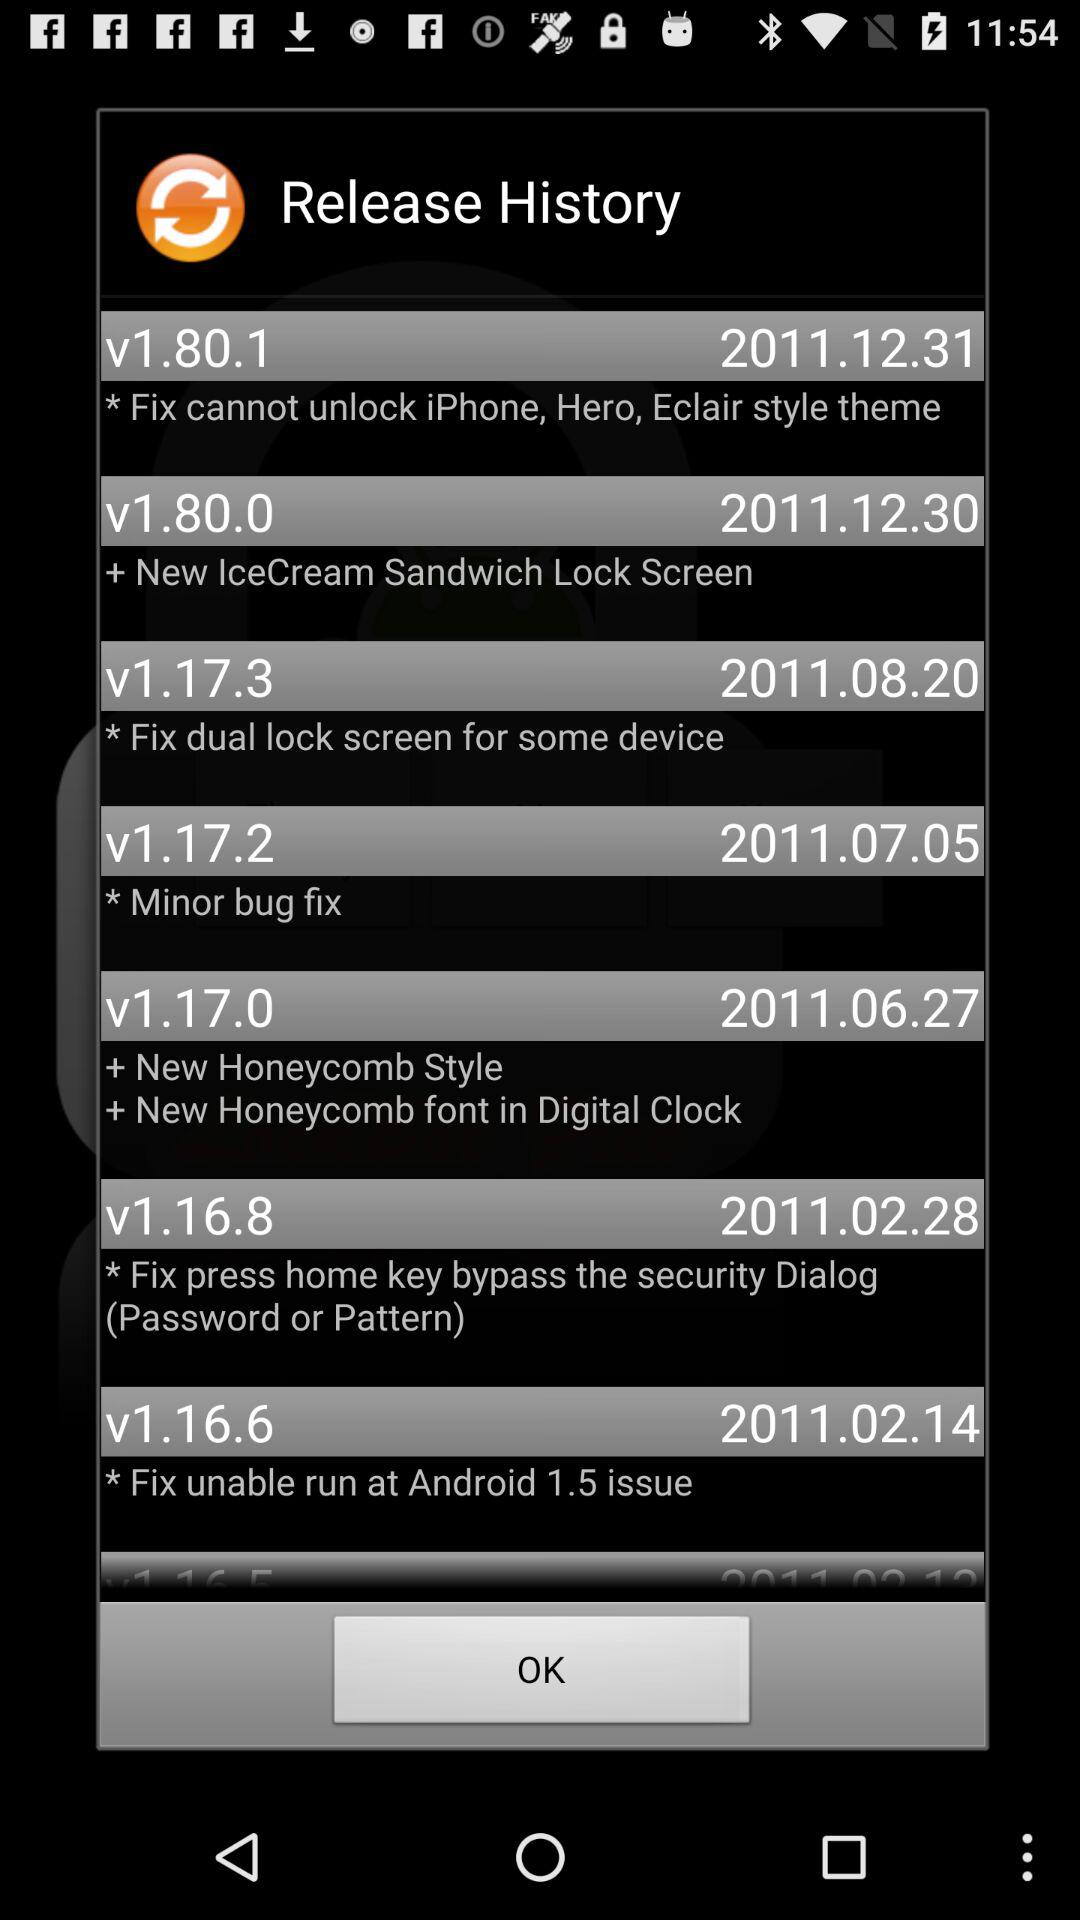What is the release date of the version number v1.80.1? The release date is December 31, 2011. 